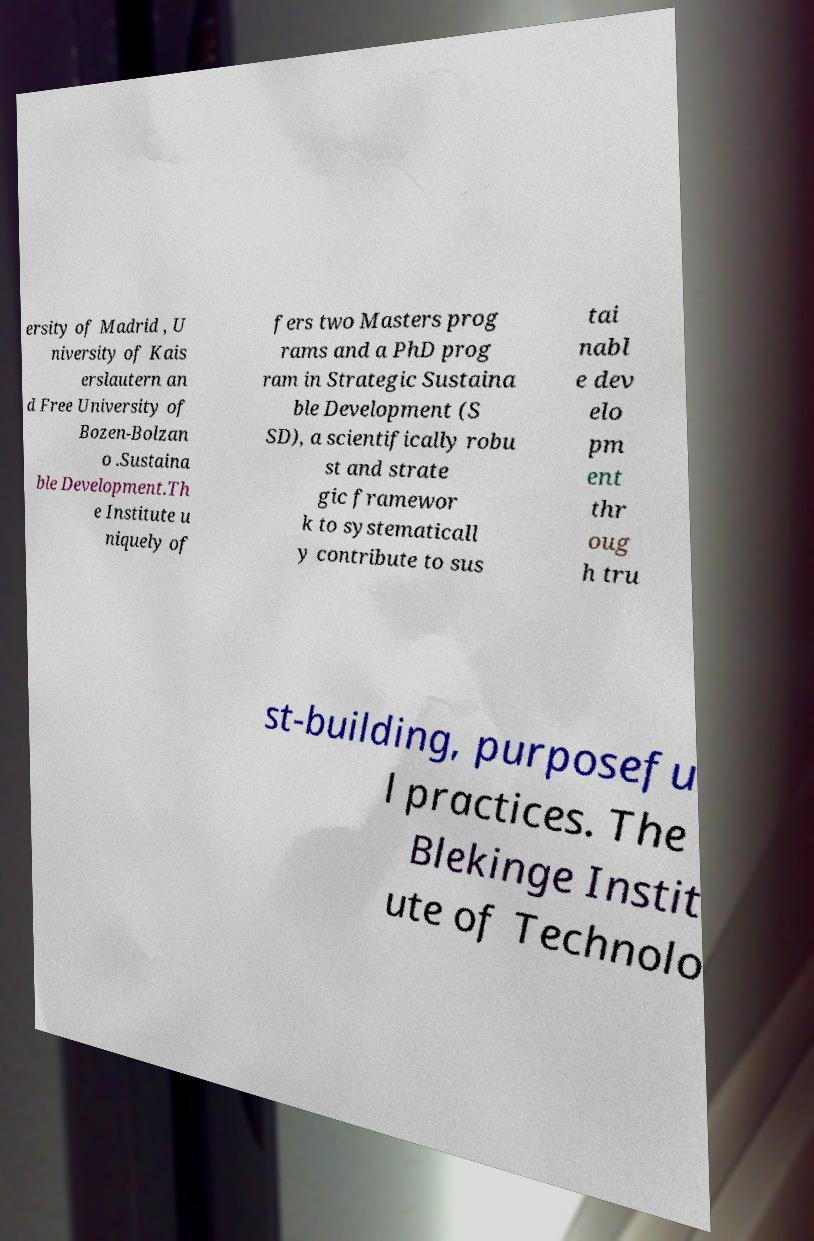Could you extract and type out the text from this image? ersity of Madrid , U niversity of Kais erslautern an d Free University of Bozen-Bolzan o .Sustaina ble Development.Th e Institute u niquely of fers two Masters prog rams and a PhD prog ram in Strategic Sustaina ble Development (S SD), a scientifically robu st and strate gic framewor k to systematicall y contribute to sus tai nabl e dev elo pm ent thr oug h tru st-building, purposefu l practices. The Blekinge Instit ute of Technolo 